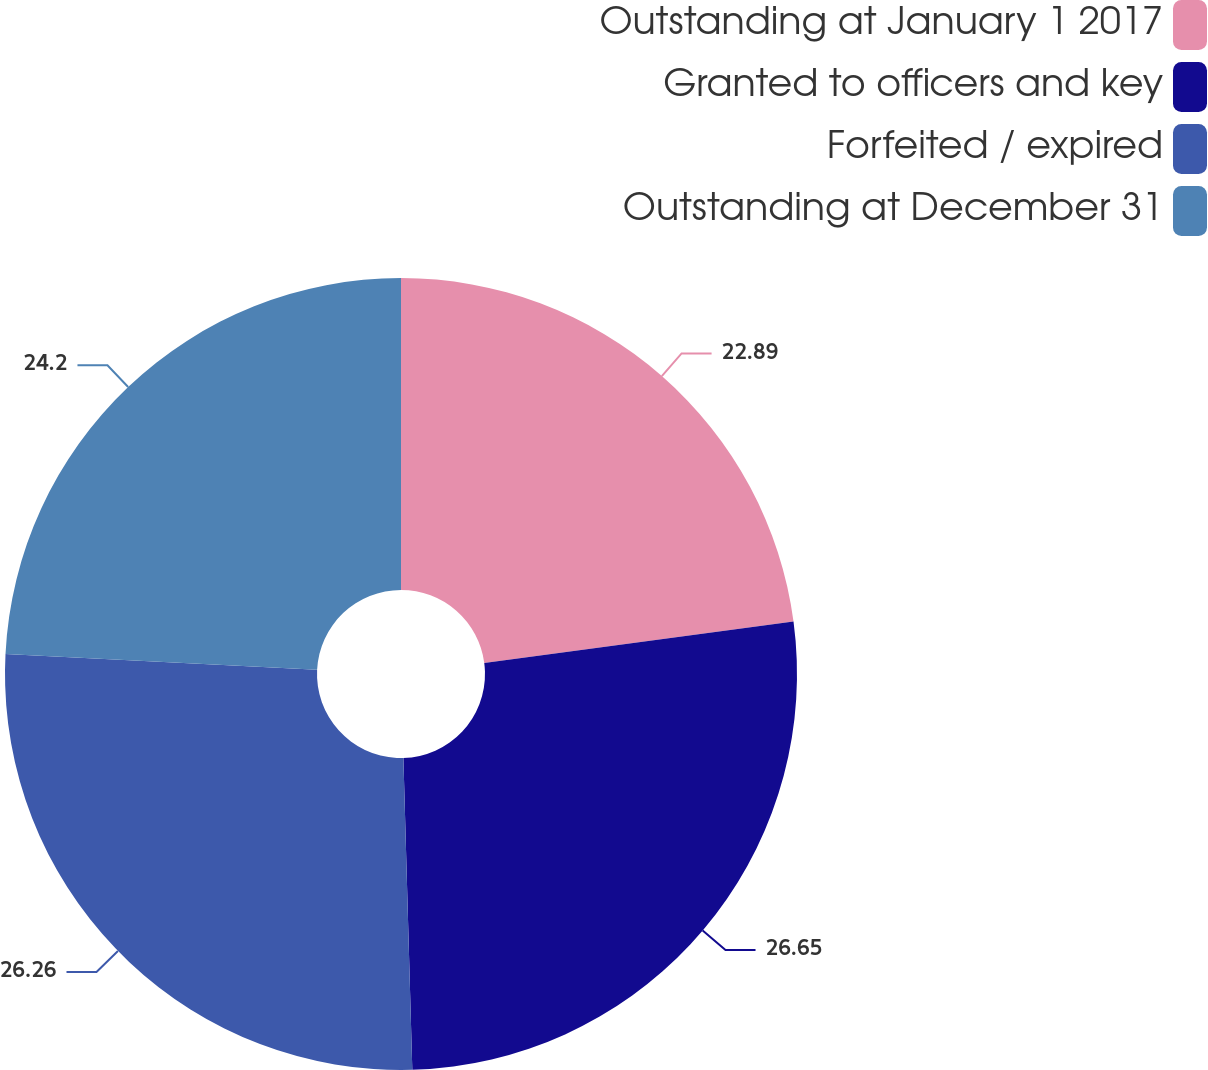<chart> <loc_0><loc_0><loc_500><loc_500><pie_chart><fcel>Outstanding at January 1 2017<fcel>Granted to officers and key<fcel>Forfeited / expired<fcel>Outstanding at December 31<nl><fcel>22.89%<fcel>26.66%<fcel>26.26%<fcel>24.2%<nl></chart> 